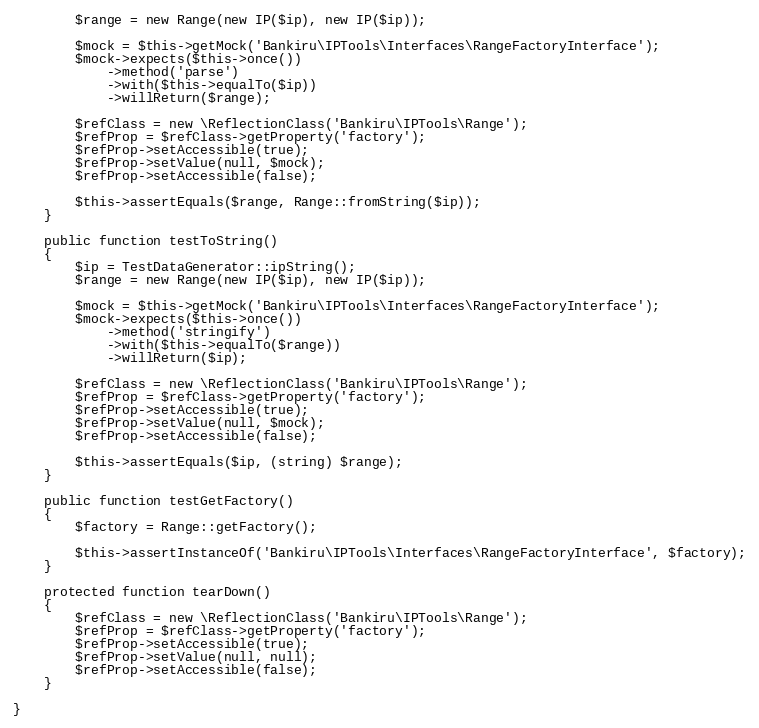Convert code to text. <code><loc_0><loc_0><loc_500><loc_500><_PHP_>        $range = new Range(new IP($ip), new IP($ip));

        $mock = $this->getMock('Bankiru\IPTools\Interfaces\RangeFactoryInterface');
        $mock->expects($this->once())
            ->method('parse')
            ->with($this->equalTo($ip))
            ->willReturn($range);

        $refClass = new \ReflectionClass('Bankiru\IPTools\Range');
        $refProp = $refClass->getProperty('factory');
        $refProp->setAccessible(true);
        $refProp->setValue(null, $mock);
        $refProp->setAccessible(false);

        $this->assertEquals($range, Range::fromString($ip));
    }

    public function testToString()
    {
        $ip = TestDataGenerator::ipString();
        $range = new Range(new IP($ip), new IP($ip));

        $mock = $this->getMock('Bankiru\IPTools\Interfaces\RangeFactoryInterface');
        $mock->expects($this->once())
            ->method('stringify')
            ->with($this->equalTo($range))
            ->willReturn($ip);

        $refClass = new \ReflectionClass('Bankiru\IPTools\Range');
        $refProp = $refClass->getProperty('factory');
        $refProp->setAccessible(true);
        $refProp->setValue(null, $mock);
        $refProp->setAccessible(false);

        $this->assertEquals($ip, (string) $range);
    }

    public function testGetFactory()
    {
        $factory = Range::getFactory();

        $this->assertInstanceOf('Bankiru\IPTools\Interfaces\RangeFactoryInterface', $factory);
    }

    protected function tearDown()
    {
        $refClass = new \ReflectionClass('Bankiru\IPTools\Range');
        $refProp = $refClass->getProperty('factory');
        $refProp->setAccessible(true);
        $refProp->setValue(null, null);
        $refProp->setAccessible(false);
    }

}
</code> 